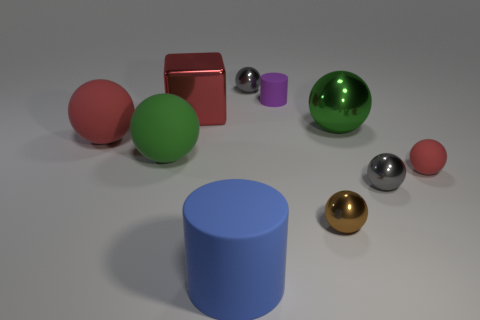What can you tell me about the lighting in the scene? The lighting in the image seems to be soft and diffused, casting gentle shadows on the ground. There is no harsh light source nor strong highlights, suggesting an evenly lit environment, likely from an overhead source. 